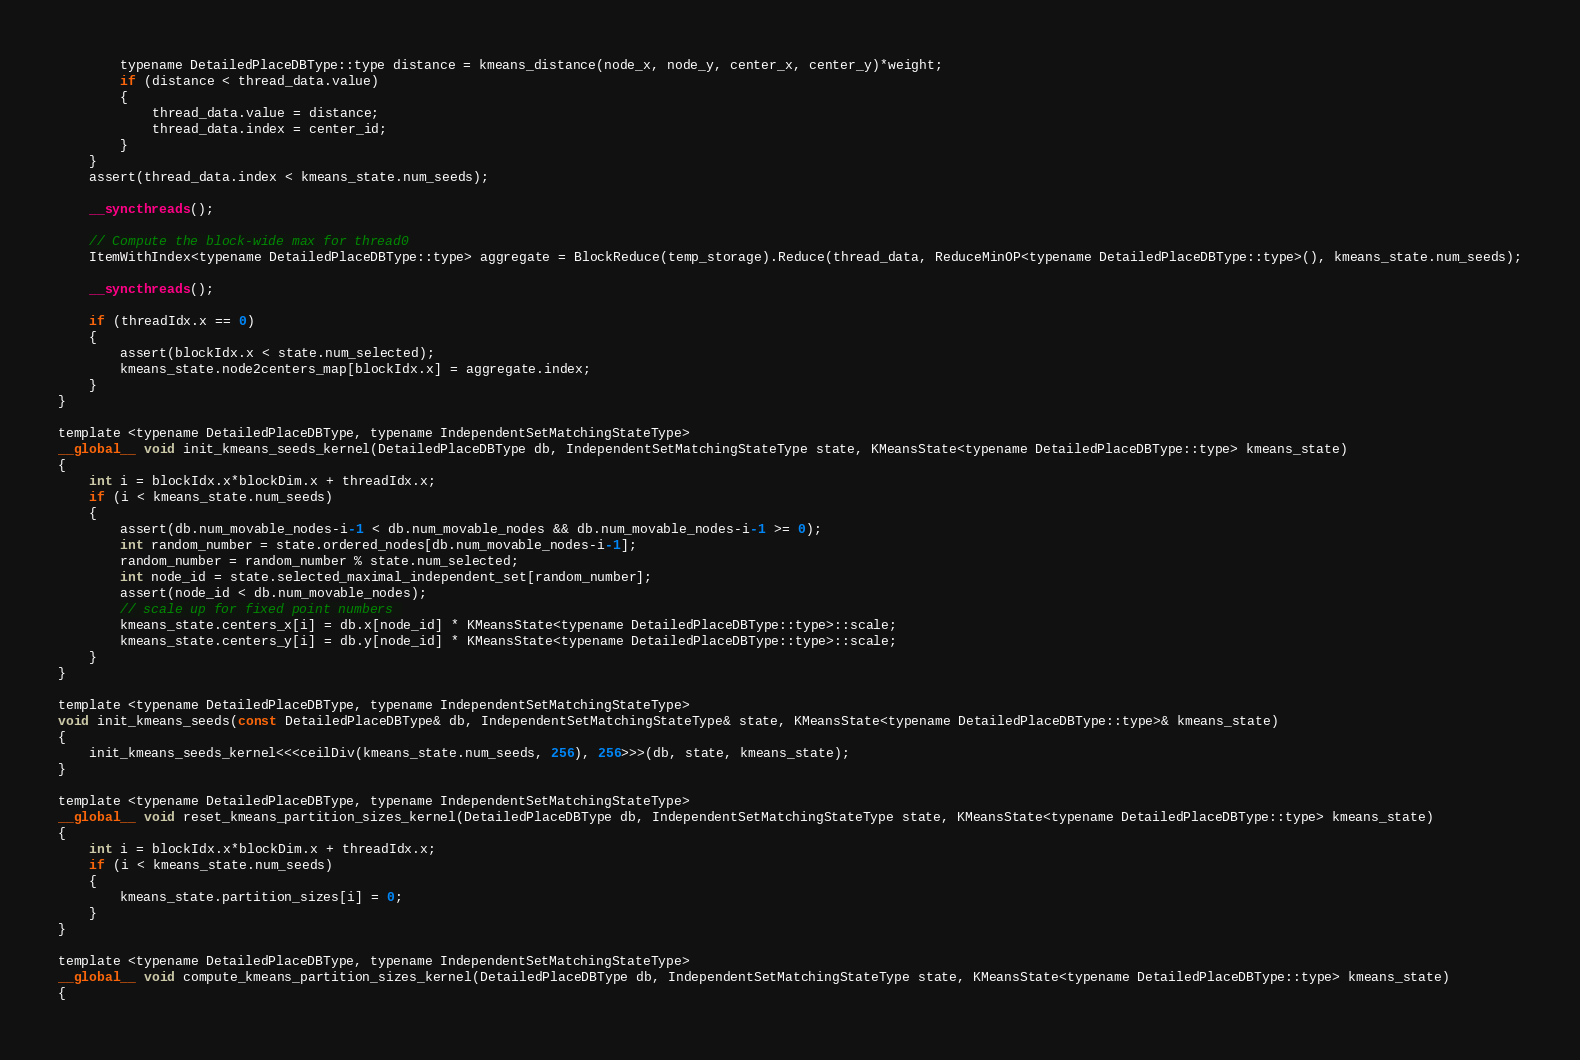Convert code to text. <code><loc_0><loc_0><loc_500><loc_500><_Cuda_>
        typename DetailedPlaceDBType::type distance = kmeans_distance(node_x, node_y, center_x, center_y)*weight; 
        if (distance < thread_data.value)
        {
            thread_data.value = distance; 
            thread_data.index = center_id; 
        }
    }
    assert(thread_data.index < kmeans_state.num_seeds);

    __syncthreads(); 

    // Compute the block-wide max for thread0
    ItemWithIndex<typename DetailedPlaceDBType::type> aggregate = BlockReduce(temp_storage).Reduce(thread_data, ReduceMinOP<typename DetailedPlaceDBType::type>(), kmeans_state.num_seeds);

    __syncthreads(); 

    if (threadIdx.x == 0)
    {
        assert(blockIdx.x < state.num_selected);
        kmeans_state.node2centers_map[blockIdx.x] = aggregate.index; 
    }
}

template <typename DetailedPlaceDBType, typename IndependentSetMatchingStateType>
__global__ void init_kmeans_seeds_kernel(DetailedPlaceDBType db, IndependentSetMatchingStateType state, KMeansState<typename DetailedPlaceDBType::type> kmeans_state)
{
    int i = blockIdx.x*blockDim.x + threadIdx.x;
    if (i < kmeans_state.num_seeds)
    {
        assert(db.num_movable_nodes-i-1 < db.num_movable_nodes && db.num_movable_nodes-i-1 >= 0);
        int random_number = state.ordered_nodes[db.num_movable_nodes-i-1]; 
        random_number = random_number % state.num_selected; 
        int node_id = state.selected_maximal_independent_set[random_number]; 
        assert(node_id < db.num_movable_nodes);
        // scale up for fixed point numbers 
        kmeans_state.centers_x[i] = db.x[node_id] * KMeansState<typename DetailedPlaceDBType::type>::scale;
        kmeans_state.centers_y[i] = db.y[node_id] * KMeansState<typename DetailedPlaceDBType::type>::scale;
    }
}

template <typename DetailedPlaceDBType, typename IndependentSetMatchingStateType>
void init_kmeans_seeds(const DetailedPlaceDBType& db, IndependentSetMatchingStateType& state, KMeansState<typename DetailedPlaceDBType::type>& kmeans_state)
{
    init_kmeans_seeds_kernel<<<ceilDiv(kmeans_state.num_seeds, 256), 256>>>(db, state, kmeans_state);
}

template <typename DetailedPlaceDBType, typename IndependentSetMatchingStateType>
__global__ void reset_kmeans_partition_sizes_kernel(DetailedPlaceDBType db, IndependentSetMatchingStateType state, KMeansState<typename DetailedPlaceDBType::type> kmeans_state)
{
    int i = blockIdx.x*blockDim.x + threadIdx.x;
    if (i < kmeans_state.num_seeds)
    {
        kmeans_state.partition_sizes[i] = 0; 
    }
}

template <typename DetailedPlaceDBType, typename IndependentSetMatchingStateType>
__global__ void compute_kmeans_partition_sizes_kernel(DetailedPlaceDBType db, IndependentSetMatchingStateType state, KMeansState<typename DetailedPlaceDBType::type> kmeans_state)
{</code> 